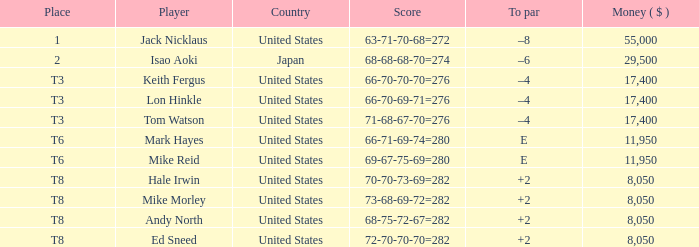What player has money larger than 11,950 and is placed in t8 and has the score of 73-68-69-72=282? None. 